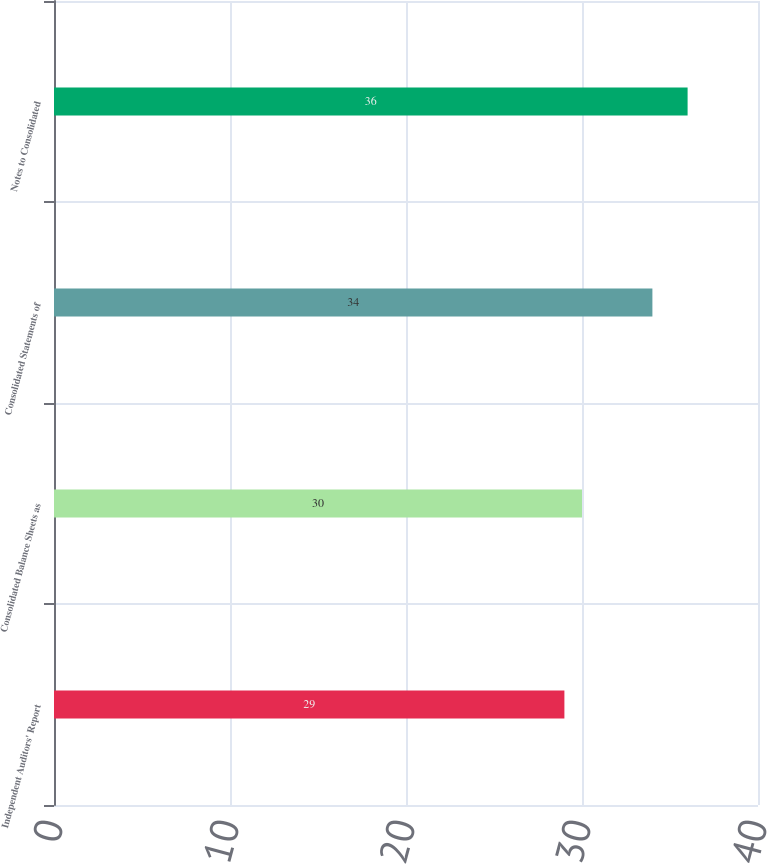<chart> <loc_0><loc_0><loc_500><loc_500><bar_chart><fcel>Independent Auditors' Report<fcel>Consolidated Balance Sheets as<fcel>Consolidated Statements of<fcel>Notes to Consolidated<nl><fcel>29<fcel>30<fcel>34<fcel>36<nl></chart> 